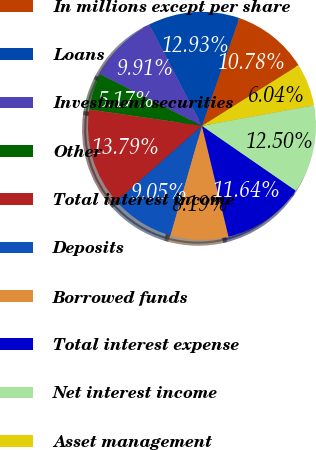<chart> <loc_0><loc_0><loc_500><loc_500><pie_chart><fcel>In millions except per share<fcel>Loans<fcel>Investment securities<fcel>Other<fcel>Total interest income<fcel>Deposits<fcel>Borrowed funds<fcel>Total interest expense<fcel>Net interest income<fcel>Asset management<nl><fcel>10.78%<fcel>12.93%<fcel>9.91%<fcel>5.17%<fcel>13.79%<fcel>9.05%<fcel>8.19%<fcel>11.64%<fcel>12.5%<fcel>6.04%<nl></chart> 